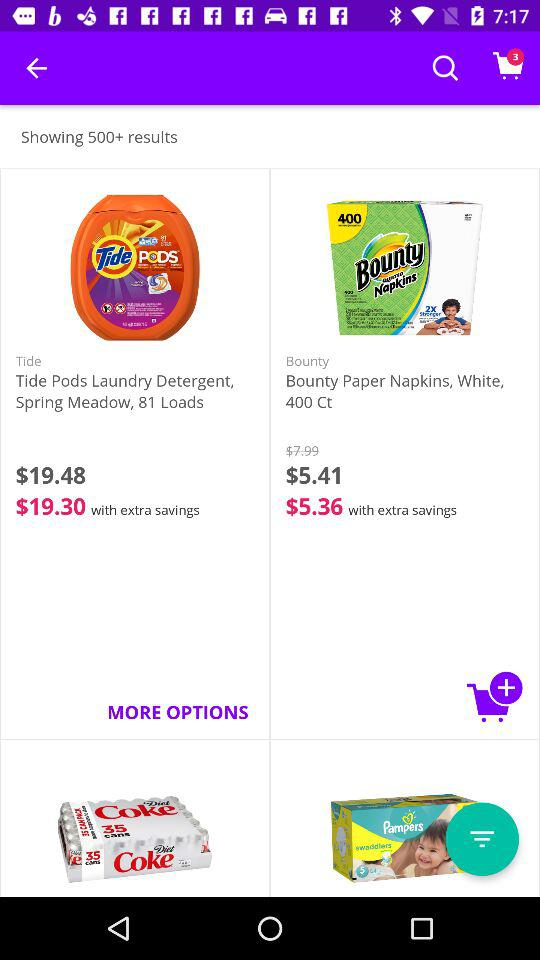How many items are in the shopping cart?
Answer the question using a single word or phrase. 3 